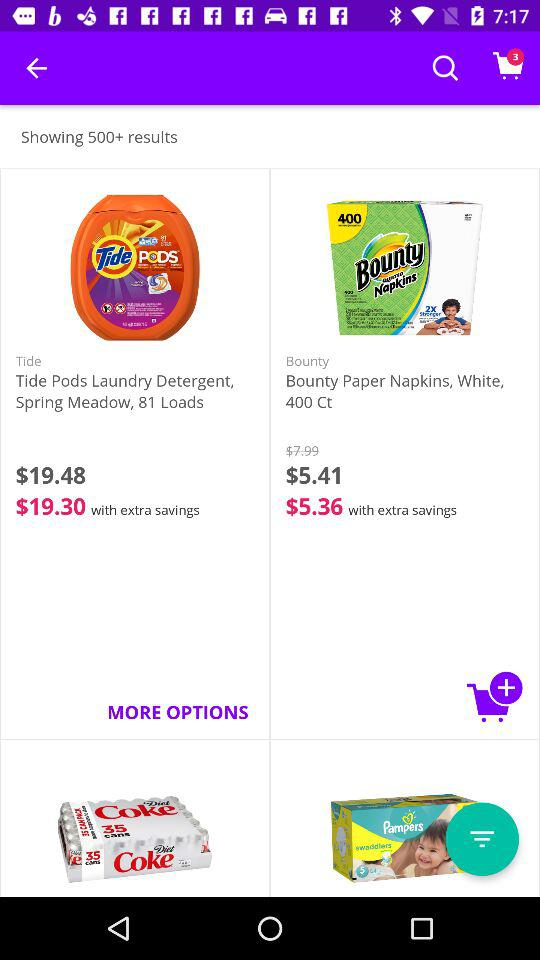How many items are in the shopping cart?
Answer the question using a single word or phrase. 3 